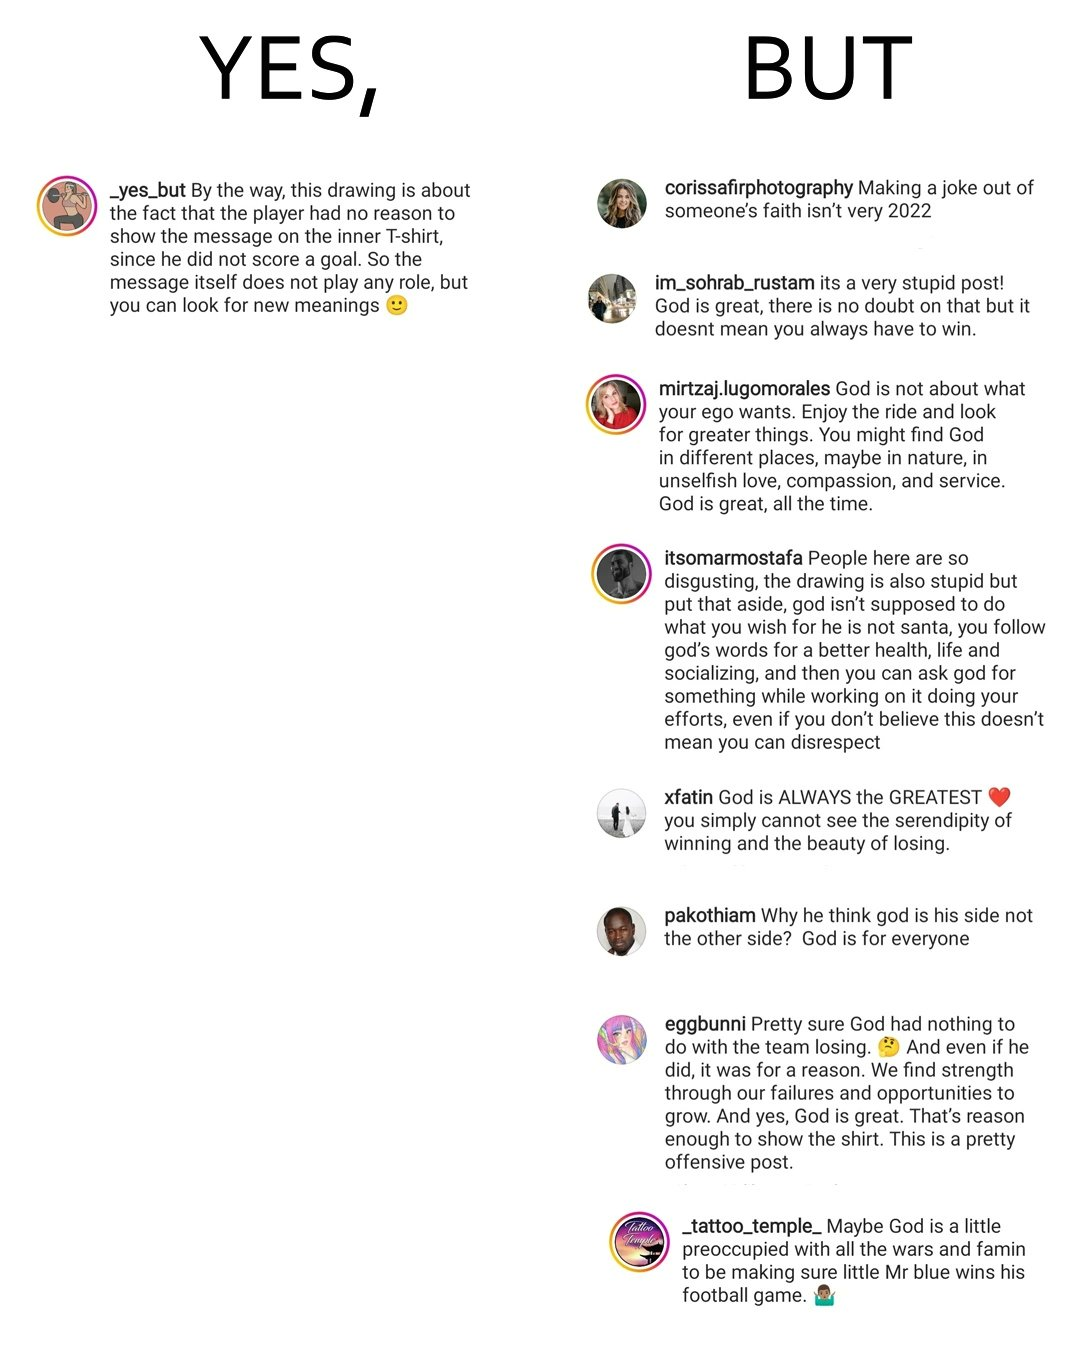Would you classify this image as satirical? Yes, this image is satirical. 